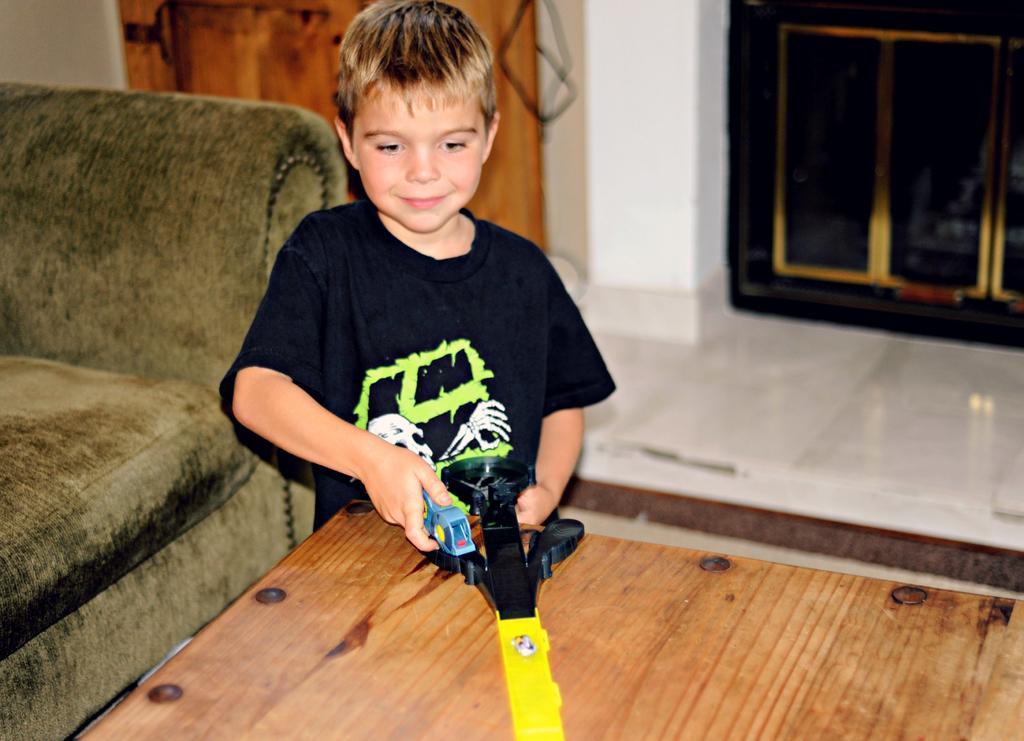Describe this image in one or two sentences. On the left side, there is a child in a black color t-shirt, holding a toy, which is on a wooden table. Behind him, there is a sofa. In the background, there is a door, a white wall and an object on a white color flower. 